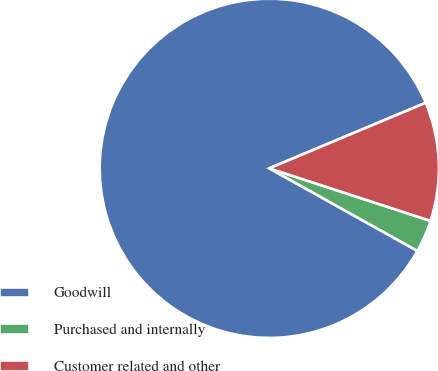<chart> <loc_0><loc_0><loc_500><loc_500><pie_chart><fcel>Goodwill<fcel>Purchased and internally<fcel>Customer related and other<nl><fcel>85.59%<fcel>3.08%<fcel>11.33%<nl></chart> 